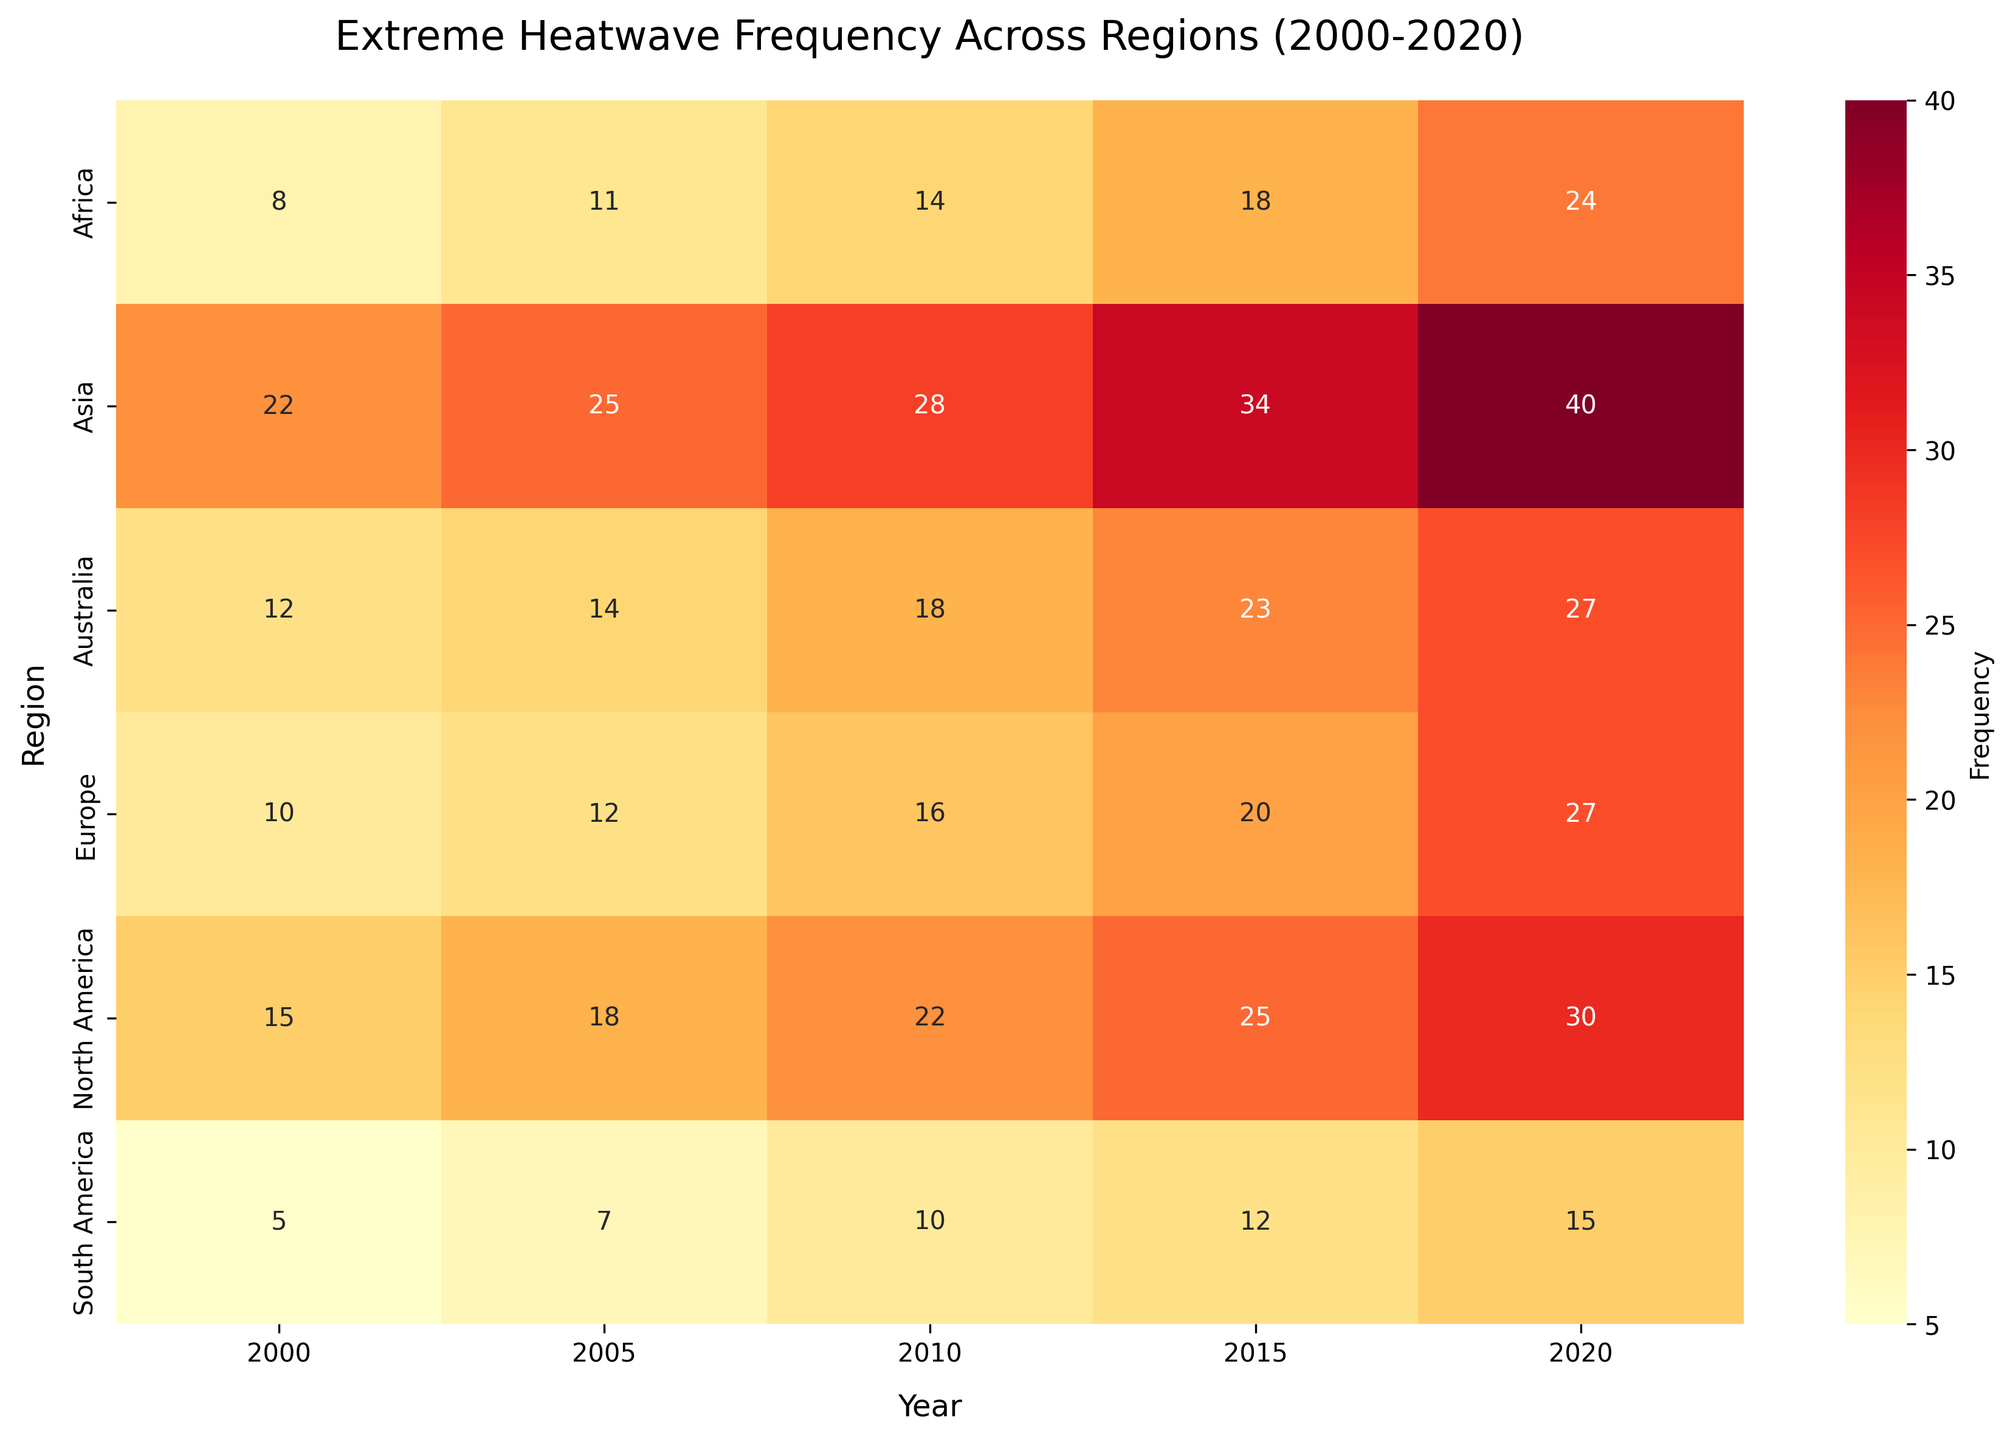What is the title of the heatmap? The title of the heatmap is written at the top center of the figure.
Answer: Extreme Heatwave Frequency Across Regions (2000-2020) Which region experienced the highest frequency of extreme heatwaves in 2020? To find the region with the highest value in 2020, look at the 2020 column and find the maximum value, then identify the corresponding region.
Answer: Asia What is the frequency of extreme heatwaves in Europe in 2015? Locate the cell where the 'Europe' row intersects with the '2015' column to find the value.
Answer: 20 Between 2000 and 2020, which region showed the greatest increase in the frequency of extreme heatwaves? Calculate the difference in frequency for each region from 2000 to 2020 and determine which region has the largest difference.
Answer: Asia On average, how many extreme heatwaves were recorded in Africa across all years displayed? Sum the values across all years for Africa and divide by the number of years (5 years). Calculation: (8 + 11 + 14 + 18 + 24) / 5 = 75 / 5.
Answer: 15 Which region had fewer than 10 extreme heatwaves in 2000? Check the '2000' column and identify regions with values less than 10.
Answer: South America, Africa Compare the frequency of extreme heatwaves between North America and Australia in 2010. Which region had more? Look at the 2010 column and compare the values for 'North America' and 'Australia'.
Answer: North America What is the average frequency of extreme heatwaves in North America over the years 2000, 2005, and 2010? Sum the values for the specified years and divide by the number of years. Calculation: (15 + 18 + 22) / 3 = 55 / 3.
Answer: 18.33 Identify a region with steadily increasing extreme heatwave frequency across all the displayed years. Observe the rows and verify whose frequency values show a consistent increase over the years.
Answer: Any of the regions, e.g., North America, Asia Which region exhibited the smallest increase in the frequency of extreme heatwaves between 2010 and 2015? Calculate the difference between 2010 and 2015 values for each region and find the smallest difference.
Answer: Africa Compare the frequency of extreme heatwaves between Asia and Europe in 2020. Which region experienced more heatwaves? Refer to the 2020 column and compare the values for 'Asia' and 'Europe'.
Answer: Asia 